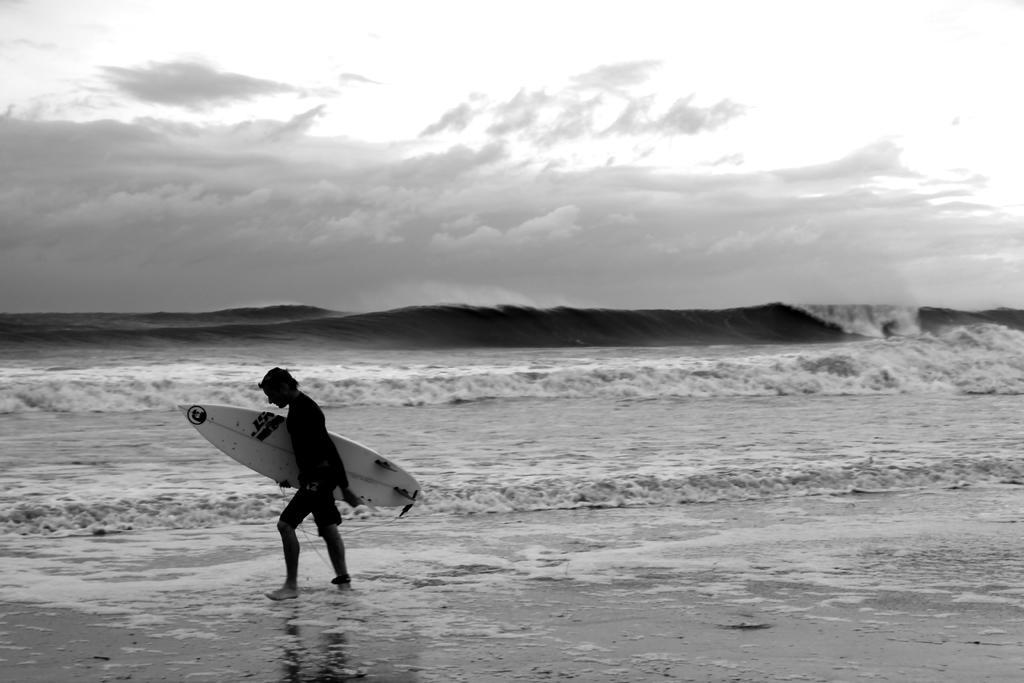How would you summarize this image in a sentence or two? In the image we can see there is a sea and there are waves which are flowing and there is a beach on which a person is walking by holding a surfer board. 